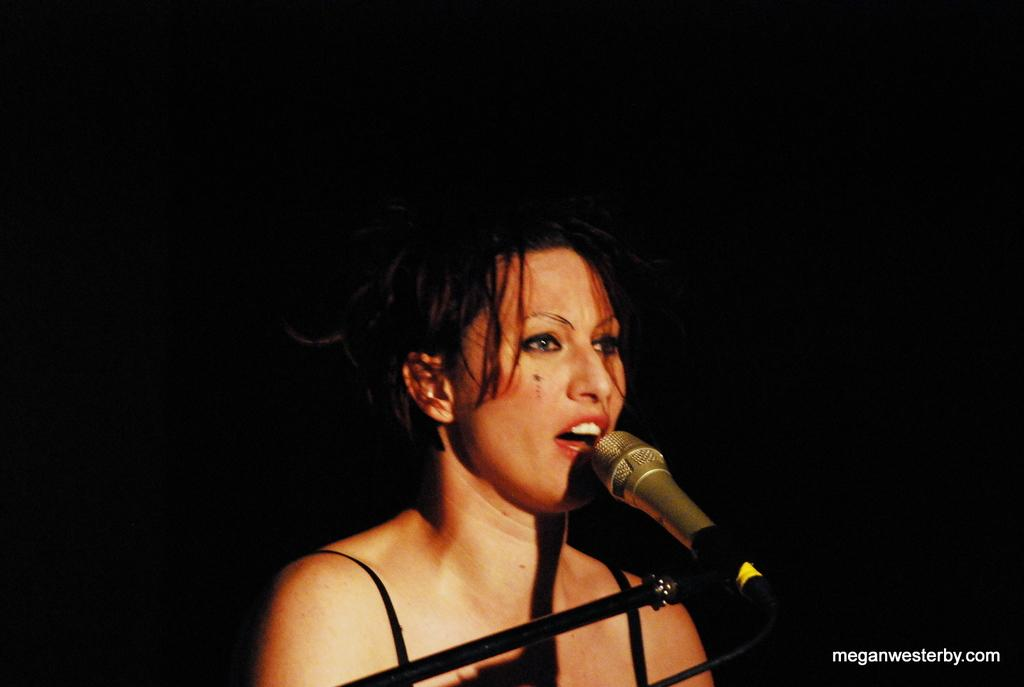Who is the main subject in the image? There is a girl in the image. Where is the girl located in the image? The girl is in the middle of the image. What object is in front of the girl? There is a mic in front of the girl. How many passengers are visible in the image? There are no passengers present in the image. Are there any babies visible in the image? There are no babies present in the image. Can you see a robin in the image? There is no robin present in the image. 